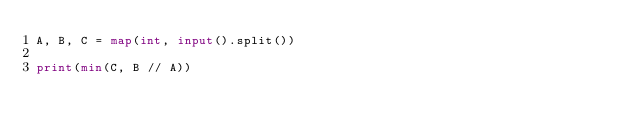Convert code to text. <code><loc_0><loc_0><loc_500><loc_500><_Python_>A, B, C = map(int, input().split())

print(min(C, B // A))
</code> 